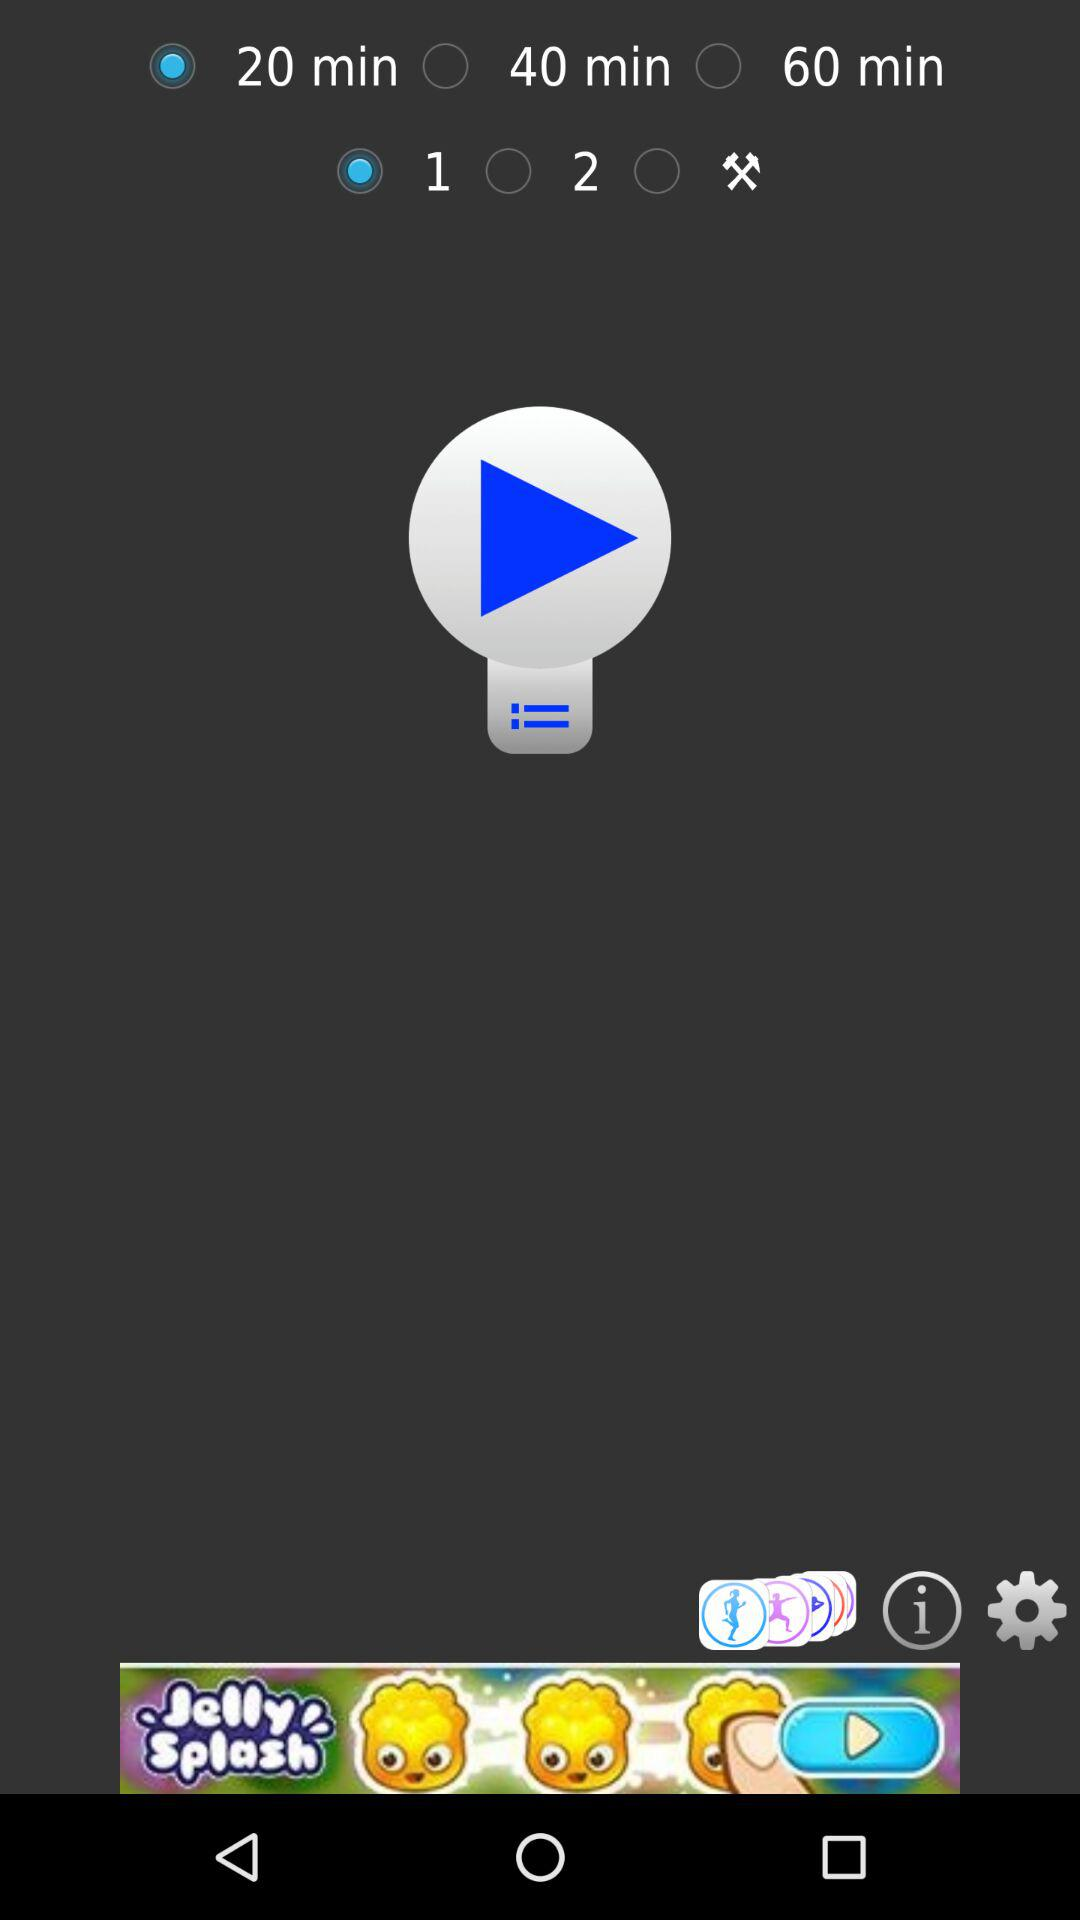What are the available options? The available options are "20 min", "40 min", "60 min", "1", "2" and "Tools". 